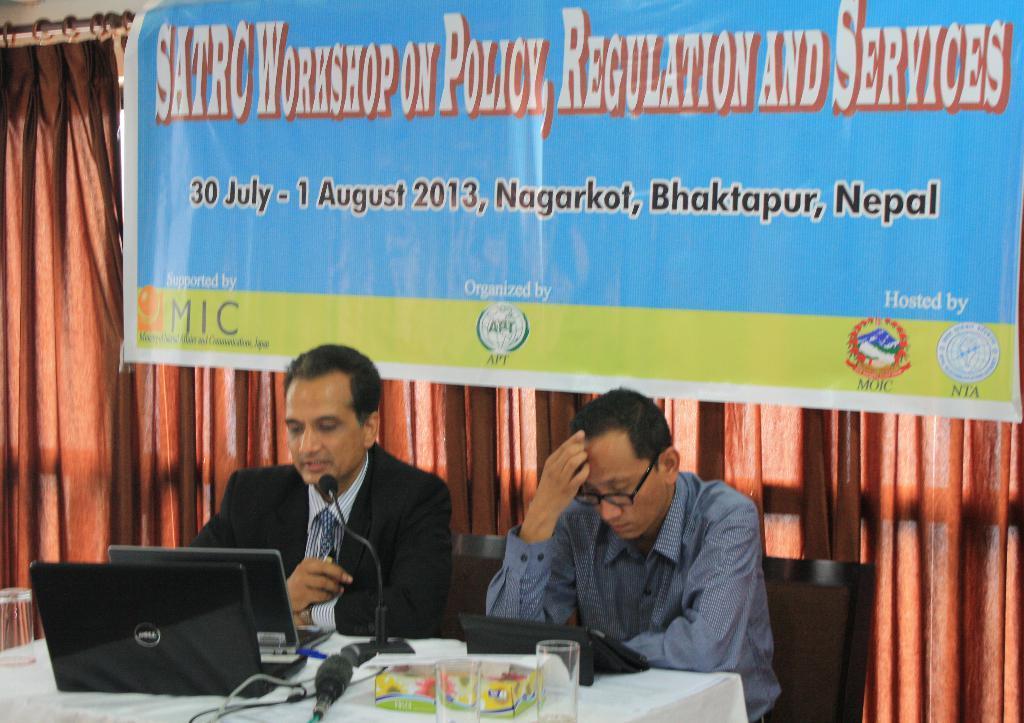In one or two sentences, can you explain what this image depicts? As we can see in the image there is a curtain, banner, two persons sitting on chairs. On table there is a glass, book, laptops and a mike. 